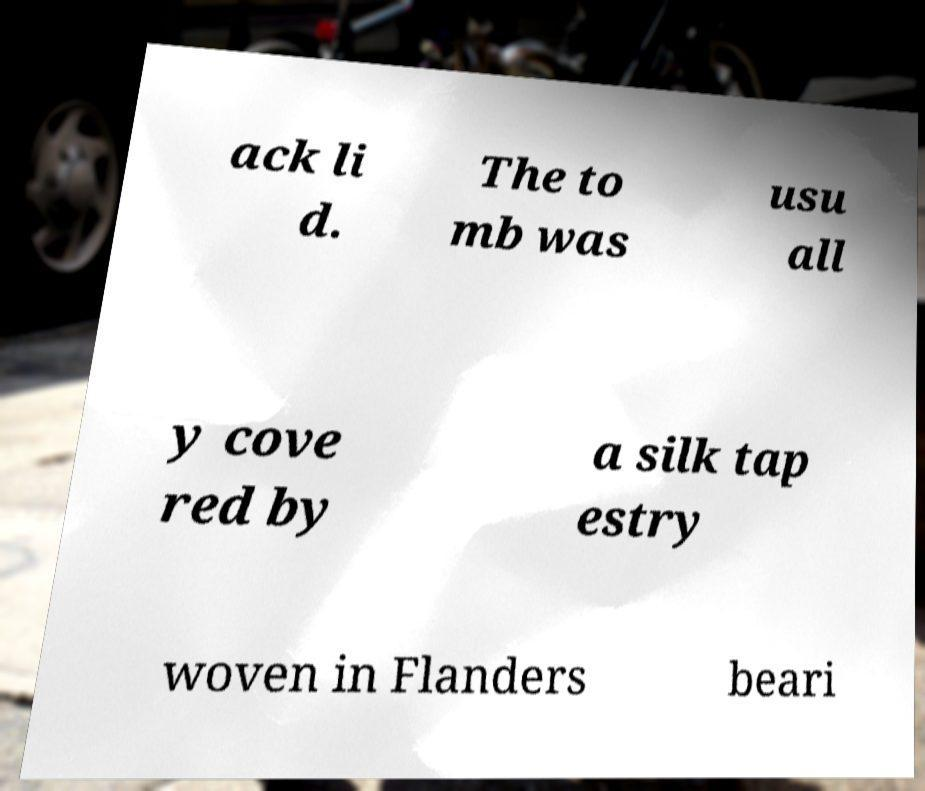Can you read and provide the text displayed in the image?This photo seems to have some interesting text. Can you extract and type it out for me? ack li d. The to mb was usu all y cove red by a silk tap estry woven in Flanders beari 